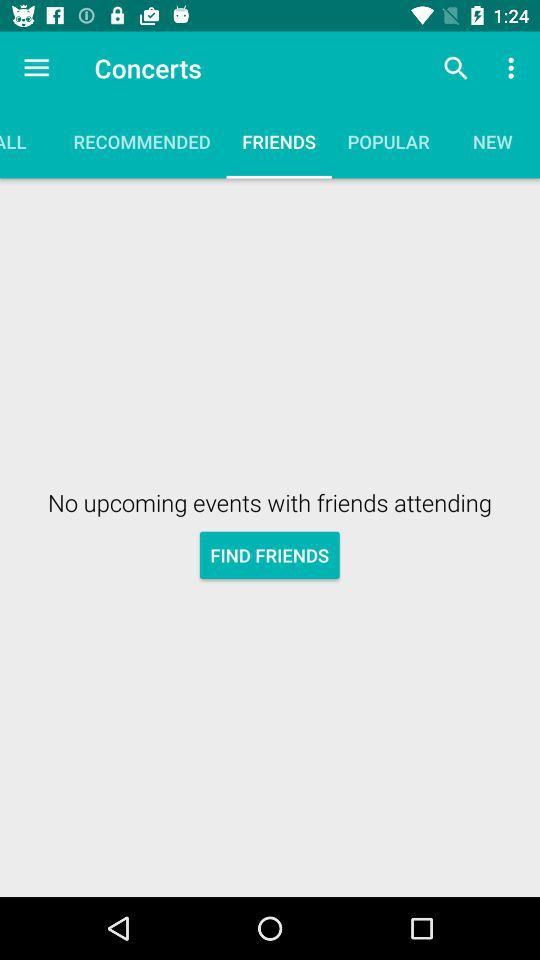How many upcoming events are there? There are no upcoming events. 